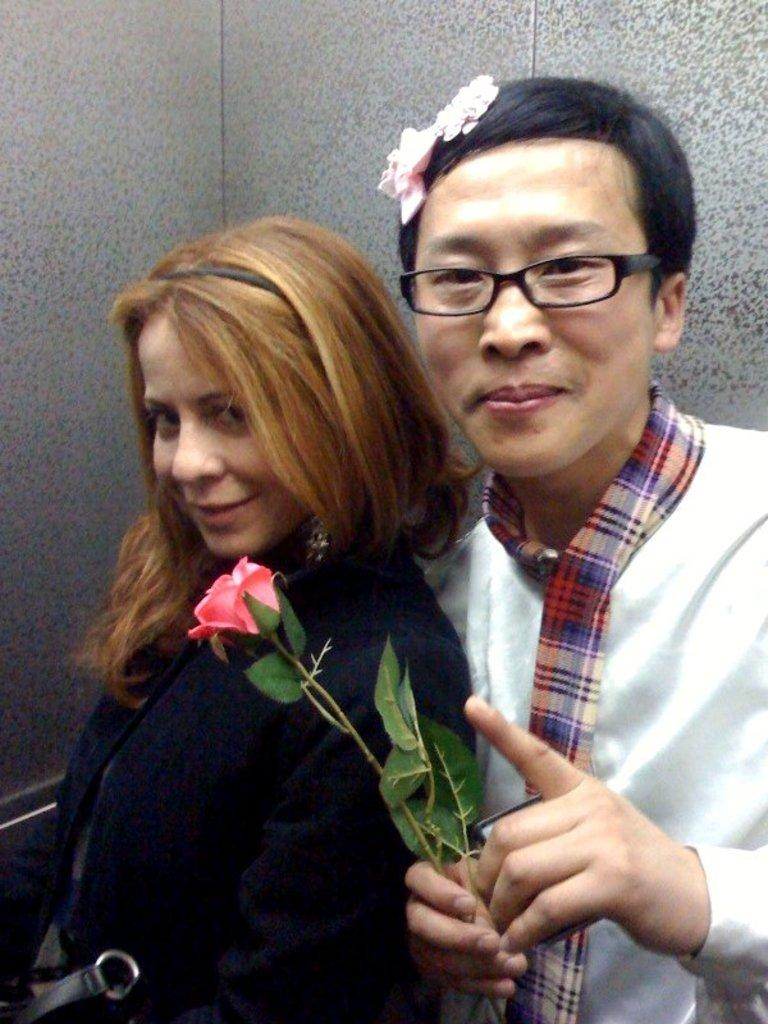How many people are in the image? There are two persons in the image. What is the right side person holding in his hand? The right side person is holding a flower in his hand. How many dogs are visible in the image? There are no dogs present in the image. Is the person on the left wearing a mask in the image? There is no mention of a mask in the image, so we cannot determine if the person on the left is wearing one. 